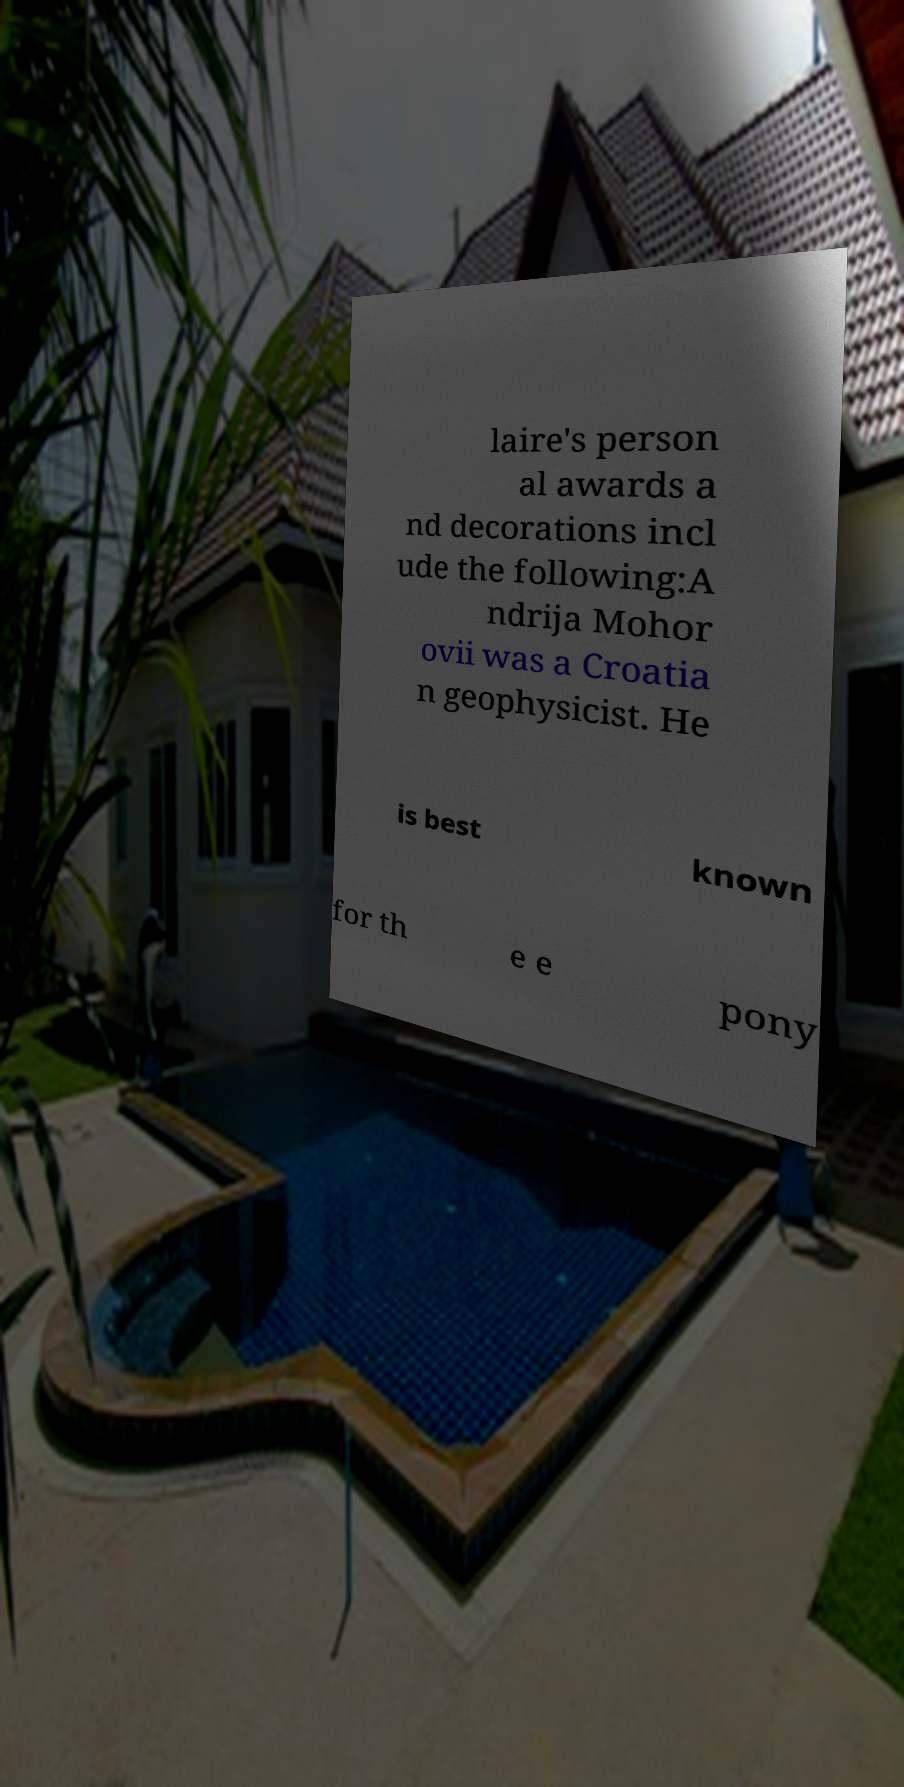Can you read and provide the text displayed in the image?This photo seems to have some interesting text. Can you extract and type it out for me? laire's person al awards a nd decorations incl ude the following:A ndrija Mohor ovii was a Croatia n geophysicist. He is best known for th e e pony 